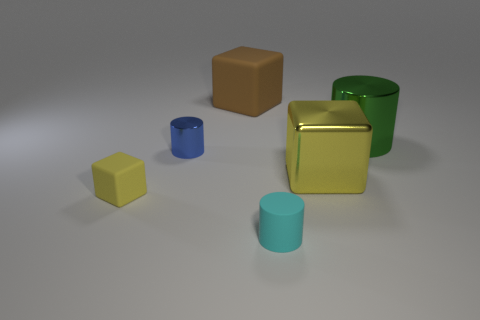Subtract all big brown rubber cubes. How many cubes are left? 2 Add 1 tiny cyan cubes. How many objects exist? 7 Subtract all green cylinders. How many cylinders are left? 2 Subtract 2 cylinders. How many cylinders are left? 1 Subtract all small blue metal objects. Subtract all cyan rubber cylinders. How many objects are left? 4 Add 2 cylinders. How many cylinders are left? 5 Add 6 green cylinders. How many green cylinders exist? 7 Subtract 2 yellow blocks. How many objects are left? 4 Subtract all red cylinders. Subtract all gray blocks. How many cylinders are left? 3 Subtract all red balls. How many cyan blocks are left? 0 